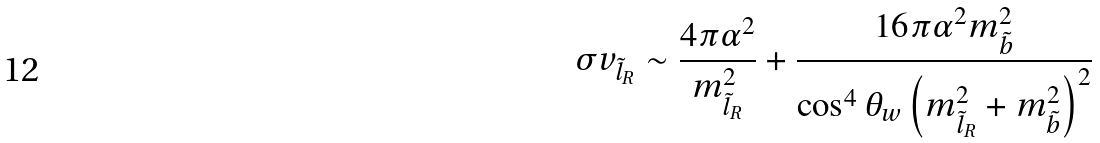Convert formula to latex. <formula><loc_0><loc_0><loc_500><loc_500>\sigma v _ { \tilde { l } _ { R } } \sim \frac { 4 \pi \alpha ^ { 2 } } { m _ { \tilde { l } _ { R } } ^ { 2 } } + \frac { 1 6 \pi \alpha ^ { 2 } m _ { \tilde { b } } ^ { 2 } } { \cos ^ { 4 } { \theta _ { w } } \left ( m _ { \tilde { l } _ { R } } ^ { 2 } + m _ { \tilde { b } } ^ { 2 } \right ) ^ { 2 } }</formula> 